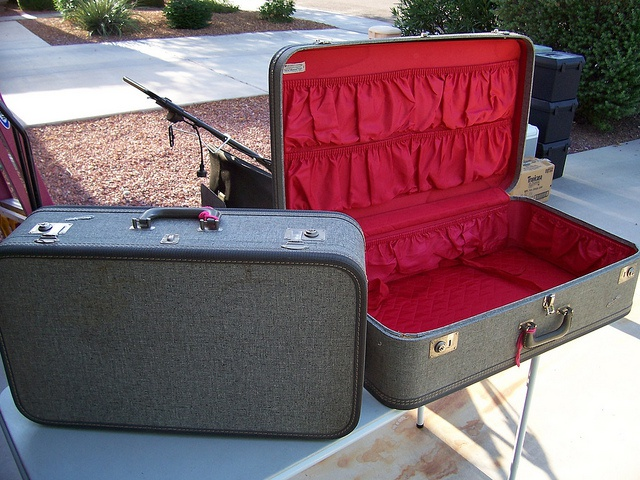Describe the objects in this image and their specific colors. I can see suitcase in black, brown, maroon, and gray tones and suitcase in black, gray, purple, and darkgray tones in this image. 